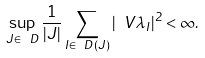Convert formula to latex. <formula><loc_0><loc_0><loc_500><loc_500>\sup _ { J \in \ D } \frac { 1 } { | J | } \sum _ { I \in \ D ( J ) } | \ V { \lambda } _ { I } | ^ { 2 } < \infty .</formula> 